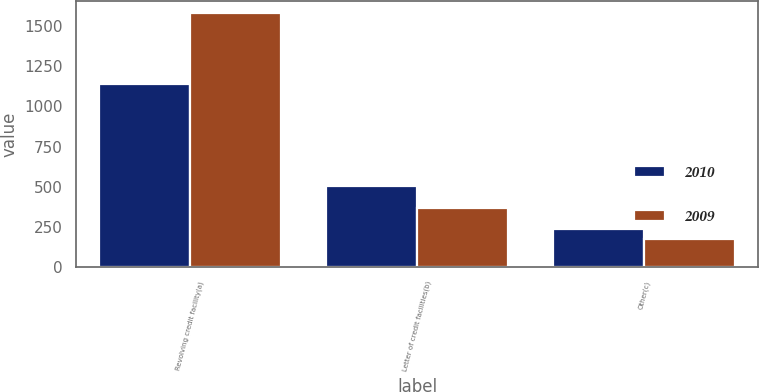Convert chart. <chart><loc_0><loc_0><loc_500><loc_500><stacked_bar_chart><ecel><fcel>Revolving credit facility(a)<fcel>Letter of credit facilities(b)<fcel>Other(c)<nl><fcel>2010<fcel>1138<fcel>505<fcel>237<nl><fcel>2009<fcel>1578<fcel>371<fcel>173<nl></chart> 